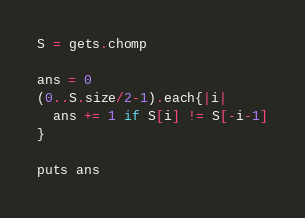Convert code to text. <code><loc_0><loc_0><loc_500><loc_500><_Ruby_>S = gets.chomp

ans = 0
(0..S.size/2-1).each{|i|
  ans += 1 if S[i] != S[-i-1]
}

puts ans
</code> 